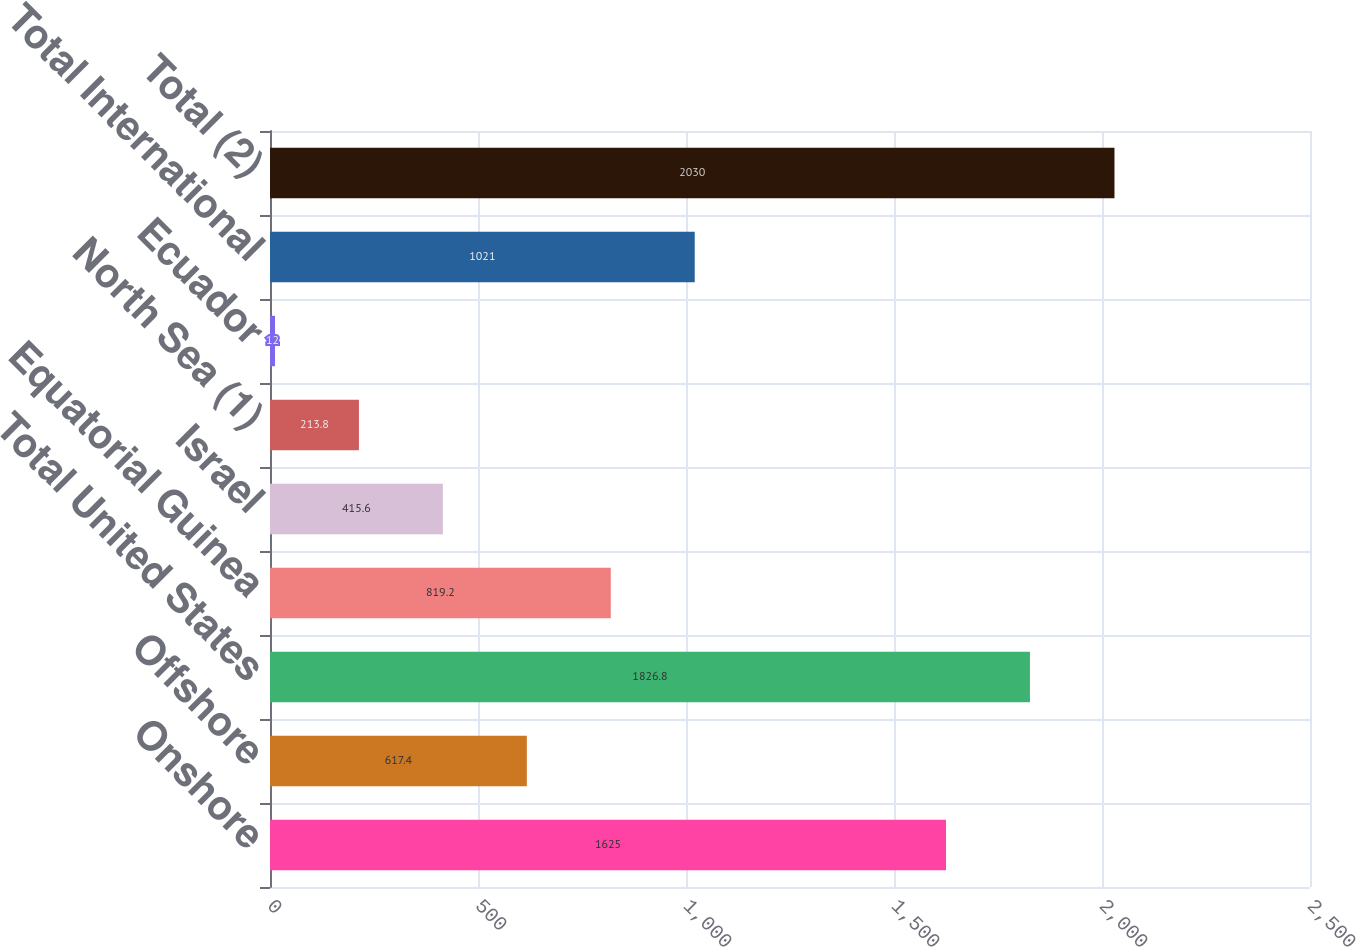Convert chart to OTSL. <chart><loc_0><loc_0><loc_500><loc_500><bar_chart><fcel>Onshore<fcel>Offshore<fcel>Total United States<fcel>Equatorial Guinea<fcel>Israel<fcel>North Sea (1)<fcel>Ecuador<fcel>Total International<fcel>Total (2)<nl><fcel>1625<fcel>617.4<fcel>1826.8<fcel>819.2<fcel>415.6<fcel>213.8<fcel>12<fcel>1021<fcel>2030<nl></chart> 